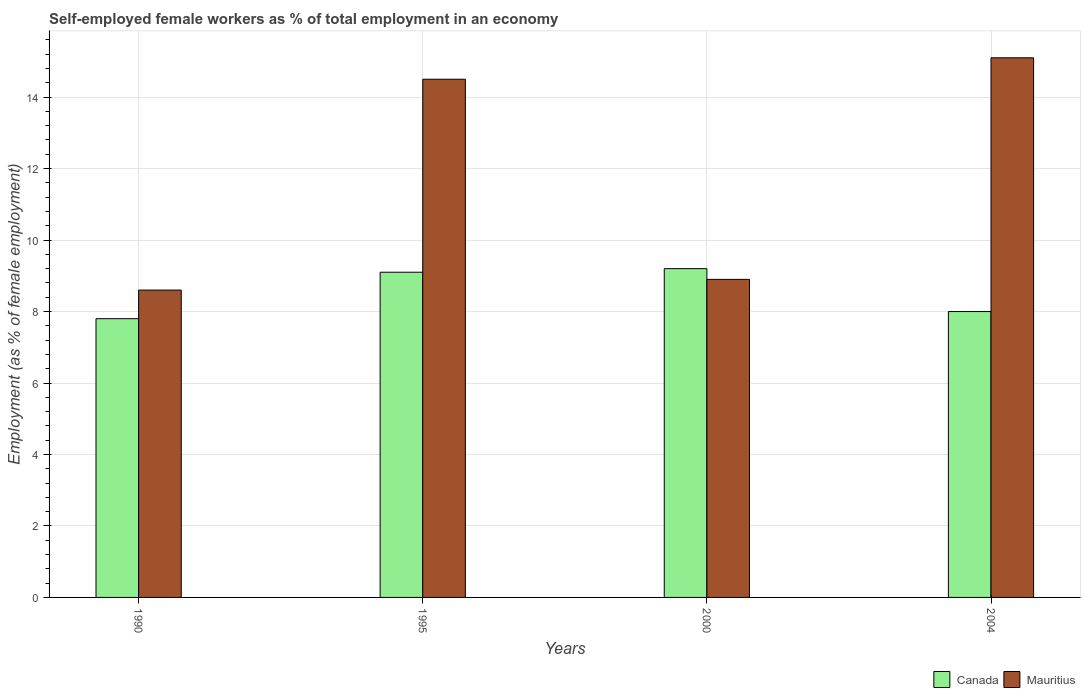How many different coloured bars are there?
Your response must be concise. 2. How many bars are there on the 3rd tick from the right?
Offer a terse response. 2. What is the label of the 3rd group of bars from the left?
Provide a succinct answer. 2000. In how many cases, is the number of bars for a given year not equal to the number of legend labels?
Your answer should be compact. 0. What is the percentage of self-employed female workers in Canada in 1995?
Your response must be concise. 9.1. Across all years, what is the maximum percentage of self-employed female workers in Mauritius?
Your response must be concise. 15.1. Across all years, what is the minimum percentage of self-employed female workers in Mauritius?
Make the answer very short. 8.6. In which year was the percentage of self-employed female workers in Mauritius minimum?
Provide a short and direct response. 1990. What is the total percentage of self-employed female workers in Mauritius in the graph?
Keep it short and to the point. 47.1. What is the difference between the percentage of self-employed female workers in Mauritius in 1990 and that in 2004?
Keep it short and to the point. -6.5. What is the difference between the percentage of self-employed female workers in Canada in 2000 and the percentage of self-employed female workers in Mauritius in 1990?
Provide a short and direct response. 0.6. What is the average percentage of self-employed female workers in Mauritius per year?
Make the answer very short. 11.78. In the year 2004, what is the difference between the percentage of self-employed female workers in Canada and percentage of self-employed female workers in Mauritius?
Ensure brevity in your answer.  -7.1. What is the ratio of the percentage of self-employed female workers in Mauritius in 1990 to that in 2004?
Provide a short and direct response. 0.57. Is the difference between the percentage of self-employed female workers in Canada in 1990 and 2000 greater than the difference between the percentage of self-employed female workers in Mauritius in 1990 and 2000?
Provide a succinct answer. No. What is the difference between the highest and the second highest percentage of self-employed female workers in Canada?
Provide a short and direct response. 0.1. What is the difference between the highest and the lowest percentage of self-employed female workers in Canada?
Offer a terse response. 1.4. What does the 2nd bar from the left in 2004 represents?
Provide a short and direct response. Mauritius. What does the 1st bar from the right in 1995 represents?
Provide a short and direct response. Mauritius. How many years are there in the graph?
Your response must be concise. 4. Are the values on the major ticks of Y-axis written in scientific E-notation?
Offer a very short reply. No. Does the graph contain any zero values?
Provide a short and direct response. No. Does the graph contain grids?
Your answer should be compact. Yes. How many legend labels are there?
Provide a short and direct response. 2. What is the title of the graph?
Give a very brief answer. Self-employed female workers as % of total employment in an economy. Does "South Asia" appear as one of the legend labels in the graph?
Provide a short and direct response. No. What is the label or title of the Y-axis?
Make the answer very short. Employment (as % of female employment). What is the Employment (as % of female employment) of Canada in 1990?
Make the answer very short. 7.8. What is the Employment (as % of female employment) of Mauritius in 1990?
Ensure brevity in your answer.  8.6. What is the Employment (as % of female employment) of Canada in 1995?
Your answer should be compact. 9.1. What is the Employment (as % of female employment) of Canada in 2000?
Ensure brevity in your answer.  9.2. What is the Employment (as % of female employment) of Mauritius in 2000?
Provide a short and direct response. 8.9. What is the Employment (as % of female employment) in Mauritius in 2004?
Make the answer very short. 15.1. Across all years, what is the maximum Employment (as % of female employment) in Canada?
Keep it short and to the point. 9.2. Across all years, what is the maximum Employment (as % of female employment) of Mauritius?
Make the answer very short. 15.1. Across all years, what is the minimum Employment (as % of female employment) in Canada?
Offer a terse response. 7.8. Across all years, what is the minimum Employment (as % of female employment) of Mauritius?
Your response must be concise. 8.6. What is the total Employment (as % of female employment) in Canada in the graph?
Provide a short and direct response. 34.1. What is the total Employment (as % of female employment) of Mauritius in the graph?
Your answer should be very brief. 47.1. What is the difference between the Employment (as % of female employment) of Canada in 1990 and that in 1995?
Ensure brevity in your answer.  -1.3. What is the difference between the Employment (as % of female employment) in Mauritius in 1990 and that in 1995?
Make the answer very short. -5.9. What is the difference between the Employment (as % of female employment) in Canada in 1990 and that in 2004?
Give a very brief answer. -0.2. What is the difference between the Employment (as % of female employment) in Canada in 1995 and that in 2000?
Ensure brevity in your answer.  -0.1. What is the difference between the Employment (as % of female employment) of Mauritius in 1995 and that in 2000?
Keep it short and to the point. 5.6. What is the difference between the Employment (as % of female employment) of Mauritius in 1995 and that in 2004?
Your answer should be very brief. -0.6. What is the difference between the Employment (as % of female employment) in Canada in 2000 and that in 2004?
Your answer should be very brief. 1.2. What is the difference between the Employment (as % of female employment) in Canada in 1990 and the Employment (as % of female employment) in Mauritius in 2000?
Provide a succinct answer. -1.1. What is the difference between the Employment (as % of female employment) in Canada in 1990 and the Employment (as % of female employment) in Mauritius in 2004?
Your answer should be compact. -7.3. What is the difference between the Employment (as % of female employment) in Canada in 1995 and the Employment (as % of female employment) in Mauritius in 2004?
Ensure brevity in your answer.  -6. What is the difference between the Employment (as % of female employment) of Canada in 2000 and the Employment (as % of female employment) of Mauritius in 2004?
Make the answer very short. -5.9. What is the average Employment (as % of female employment) of Canada per year?
Provide a succinct answer. 8.53. What is the average Employment (as % of female employment) of Mauritius per year?
Offer a very short reply. 11.78. What is the ratio of the Employment (as % of female employment) of Mauritius in 1990 to that in 1995?
Keep it short and to the point. 0.59. What is the ratio of the Employment (as % of female employment) of Canada in 1990 to that in 2000?
Keep it short and to the point. 0.85. What is the ratio of the Employment (as % of female employment) of Mauritius in 1990 to that in 2000?
Ensure brevity in your answer.  0.97. What is the ratio of the Employment (as % of female employment) in Canada in 1990 to that in 2004?
Your response must be concise. 0.97. What is the ratio of the Employment (as % of female employment) of Mauritius in 1990 to that in 2004?
Your response must be concise. 0.57. What is the ratio of the Employment (as % of female employment) of Canada in 1995 to that in 2000?
Keep it short and to the point. 0.99. What is the ratio of the Employment (as % of female employment) of Mauritius in 1995 to that in 2000?
Give a very brief answer. 1.63. What is the ratio of the Employment (as % of female employment) of Canada in 1995 to that in 2004?
Your answer should be compact. 1.14. What is the ratio of the Employment (as % of female employment) of Mauritius in 1995 to that in 2004?
Ensure brevity in your answer.  0.96. What is the ratio of the Employment (as % of female employment) of Canada in 2000 to that in 2004?
Your answer should be compact. 1.15. What is the ratio of the Employment (as % of female employment) in Mauritius in 2000 to that in 2004?
Your answer should be very brief. 0.59. 